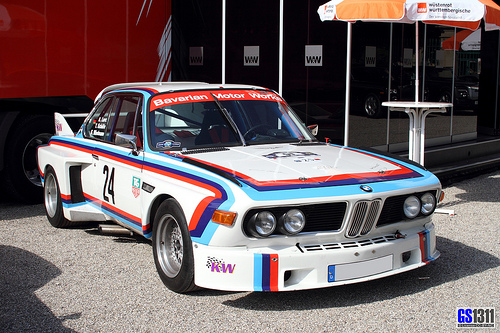<image>
Can you confirm if the stand is to the left of the car? Yes. From this viewpoint, the stand is positioned to the left side relative to the car. 